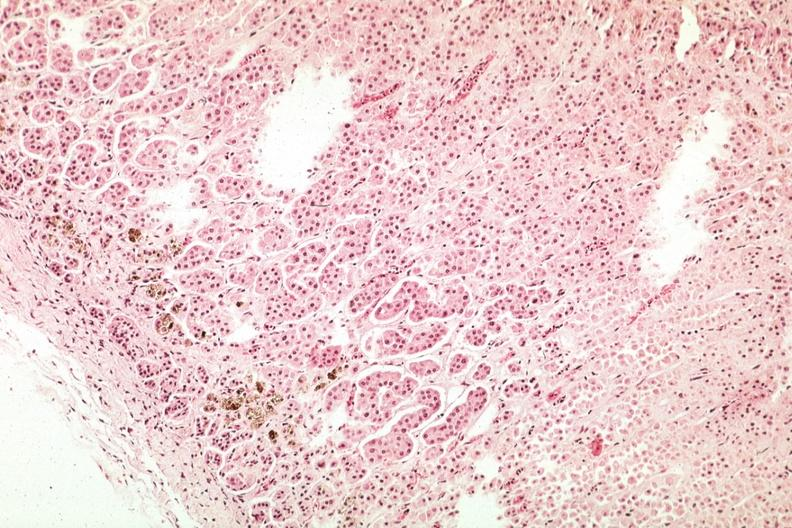s very good example present?
Answer the question using a single word or phrase. No 